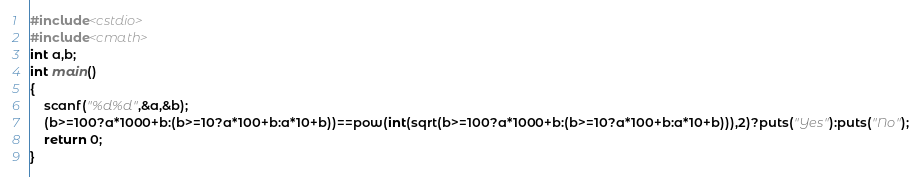<code> <loc_0><loc_0><loc_500><loc_500><_C++_>#include<cstdio>
#include<cmath>
int a,b;
int main()
{
	scanf("%d%d",&a,&b);
	(b>=100?a*1000+b:(b>=10?a*100+b:a*10+b))==pow(int(sqrt(b>=100?a*1000+b:(b>=10?a*100+b:a*10+b))),2)?puts("Yes"):puts("No");
	return 0;
}</code> 